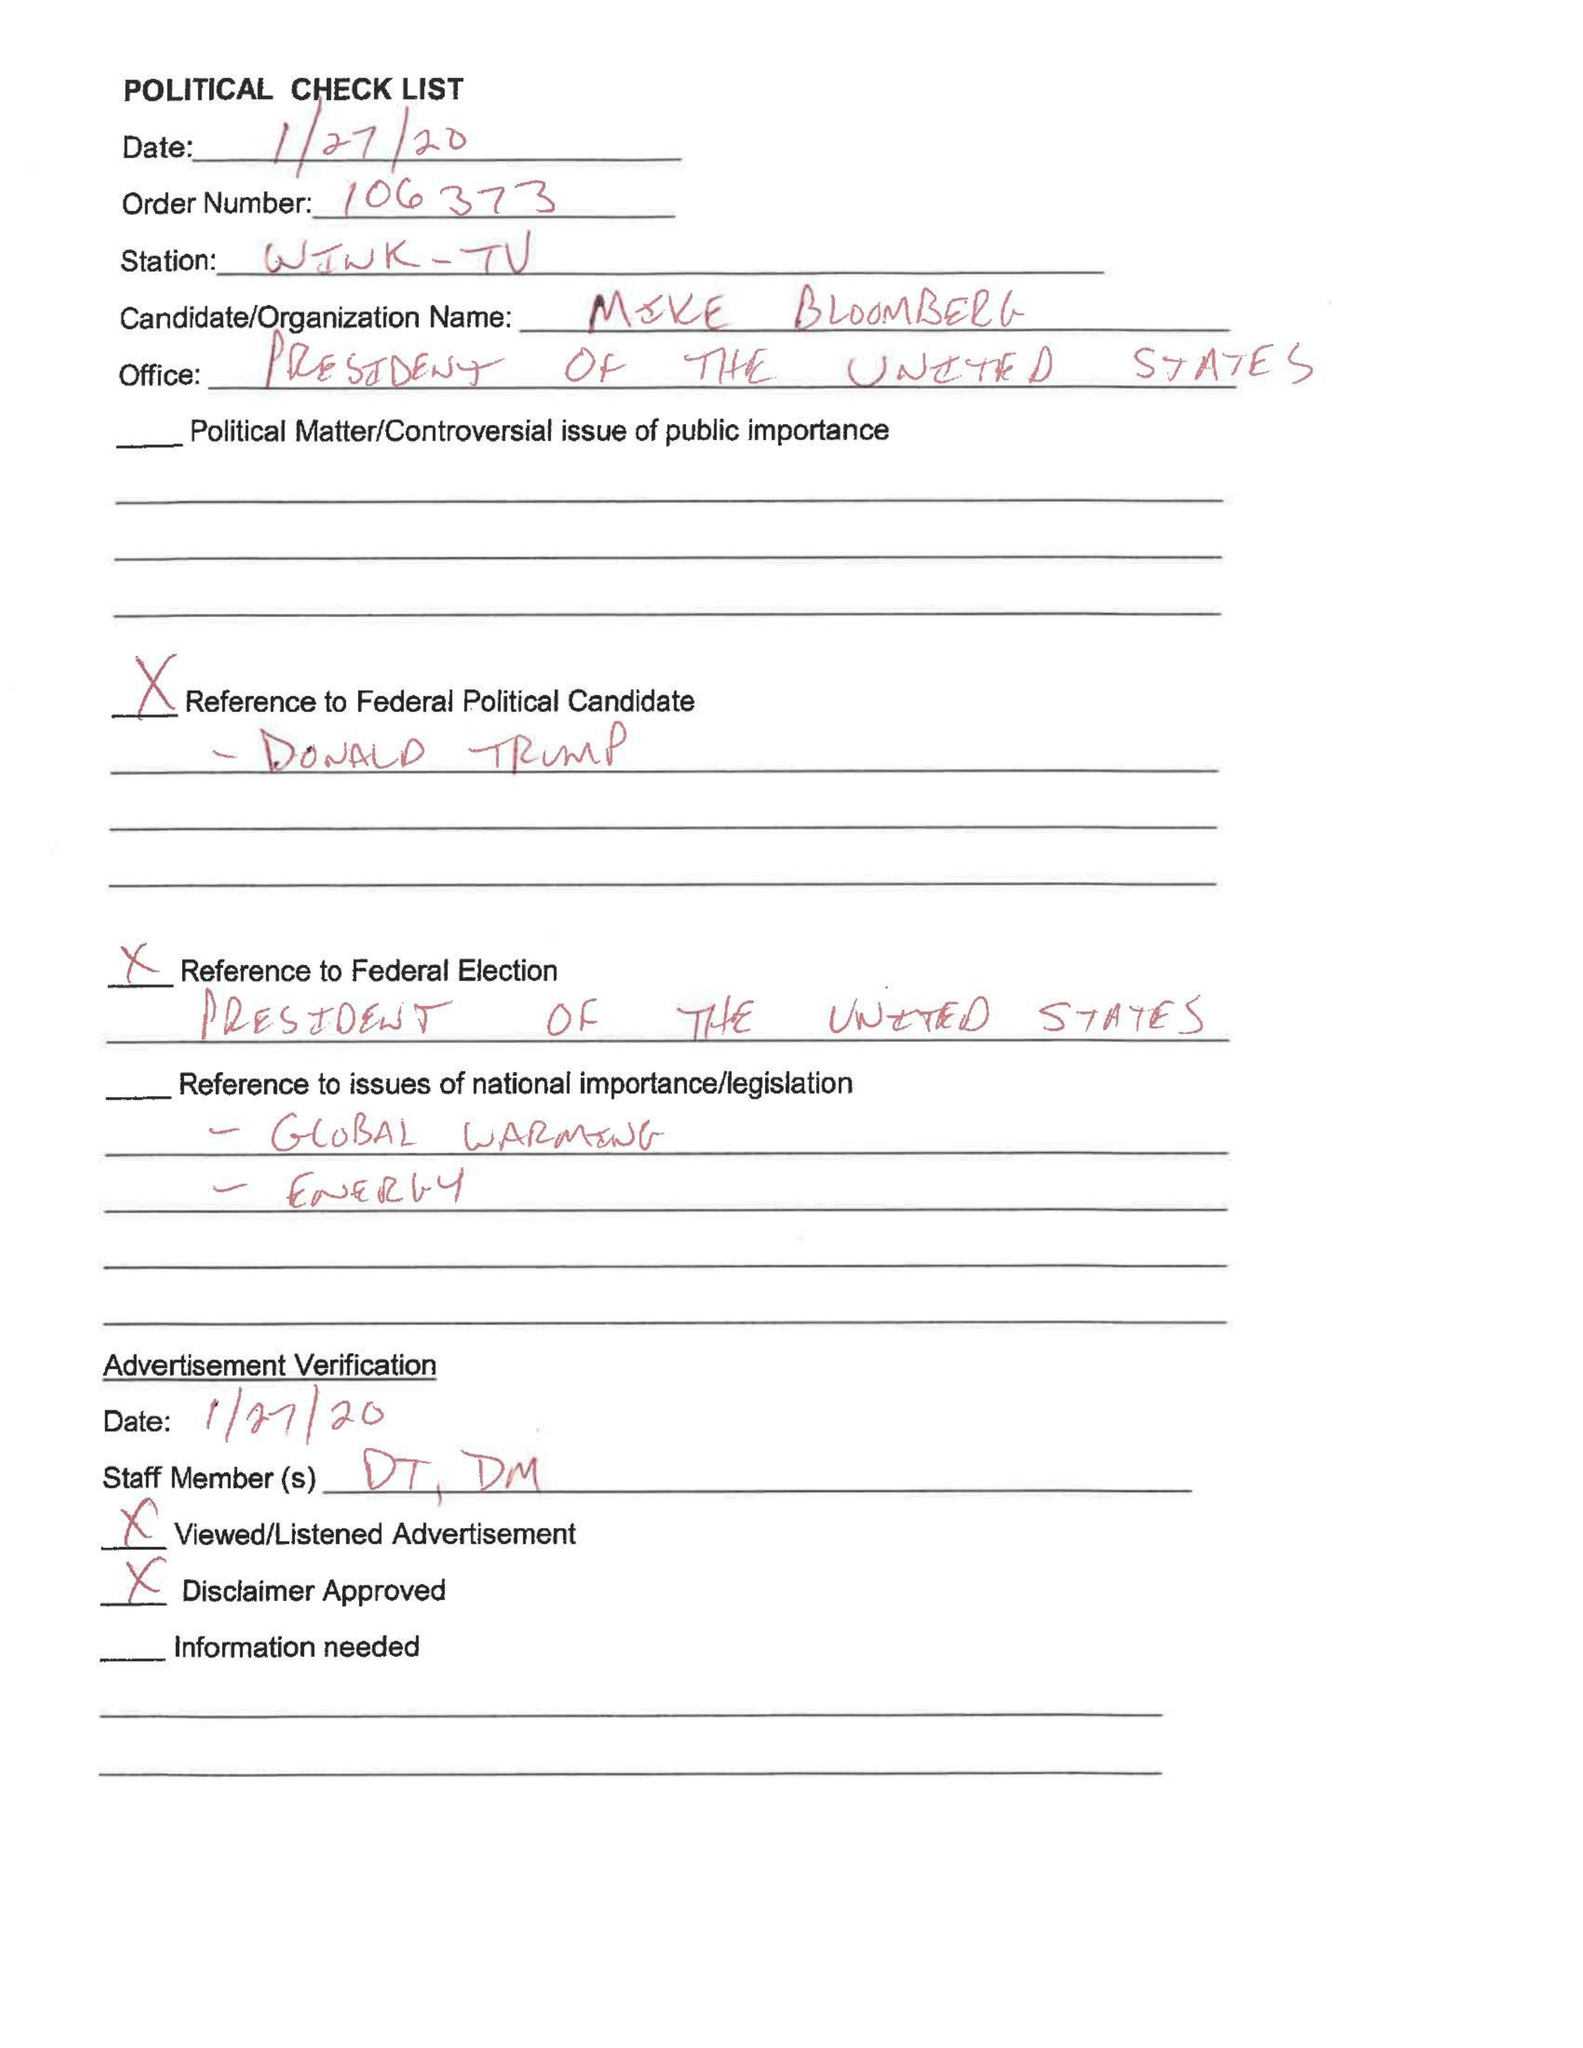What is the value for the advertiser?
Answer the question using a single word or phrase. None 